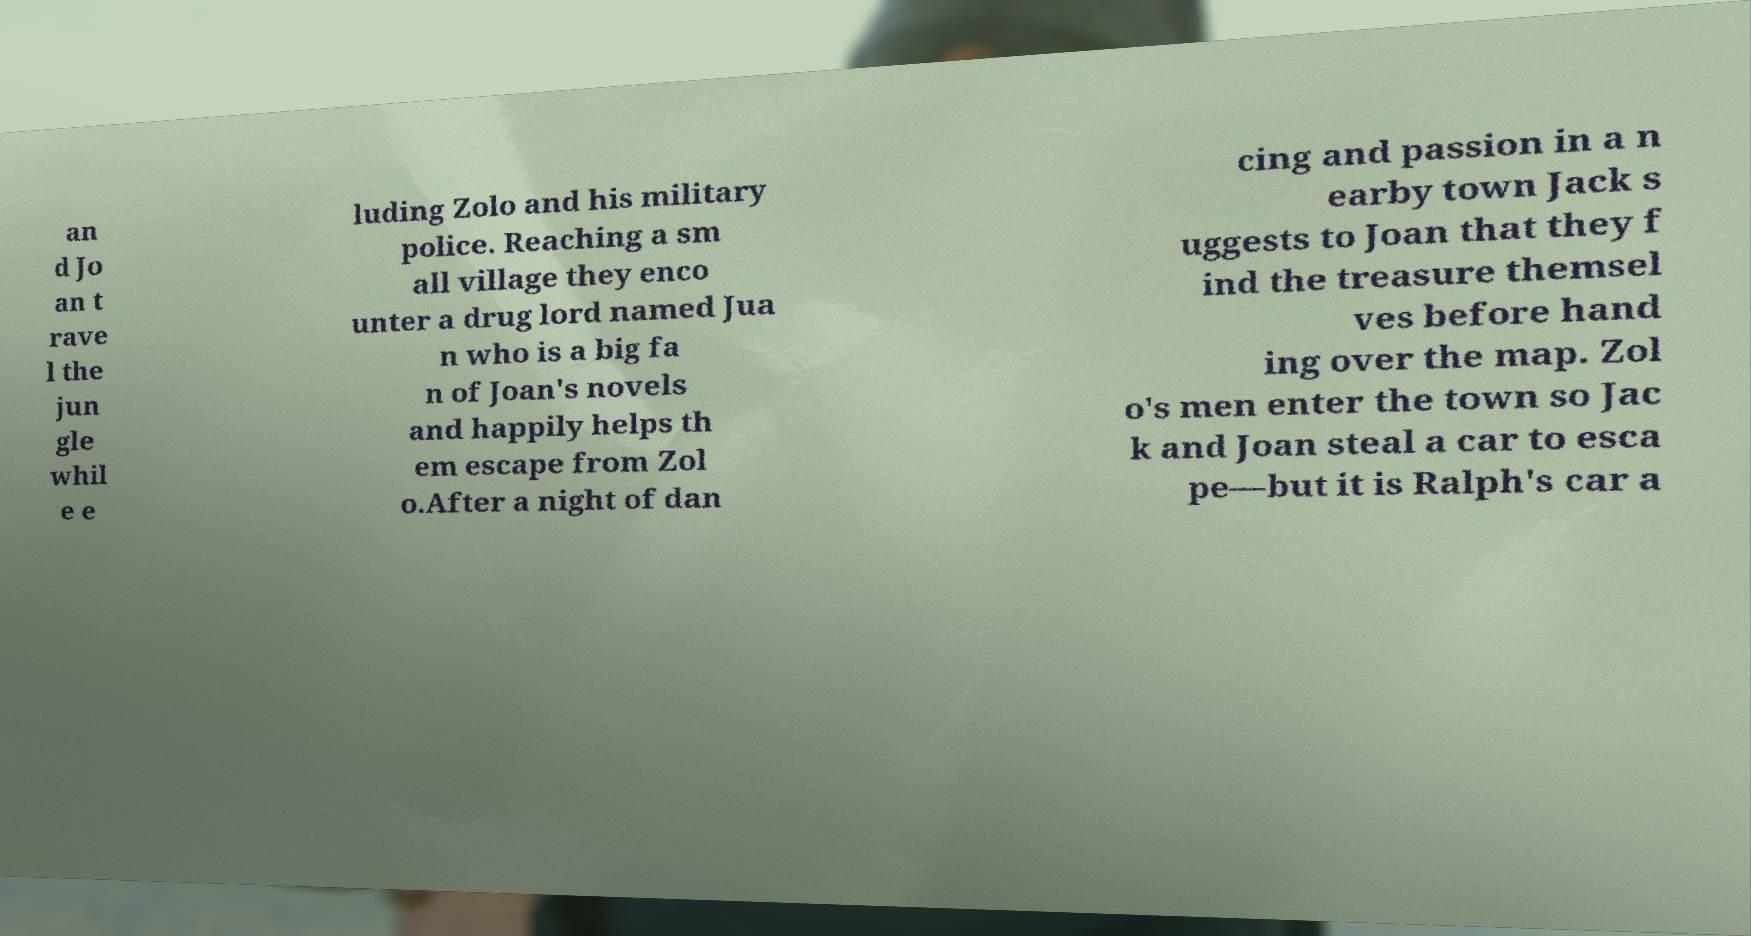Can you read and provide the text displayed in the image?This photo seems to have some interesting text. Can you extract and type it out for me? an d Jo an t rave l the jun gle whil e e luding Zolo and his military police. Reaching a sm all village they enco unter a drug lord named Jua n who is a big fa n of Joan's novels and happily helps th em escape from Zol o.After a night of dan cing and passion in a n earby town Jack s uggests to Joan that they f ind the treasure themsel ves before hand ing over the map. Zol o's men enter the town so Jac k and Joan steal a car to esca pe—but it is Ralph's car a 